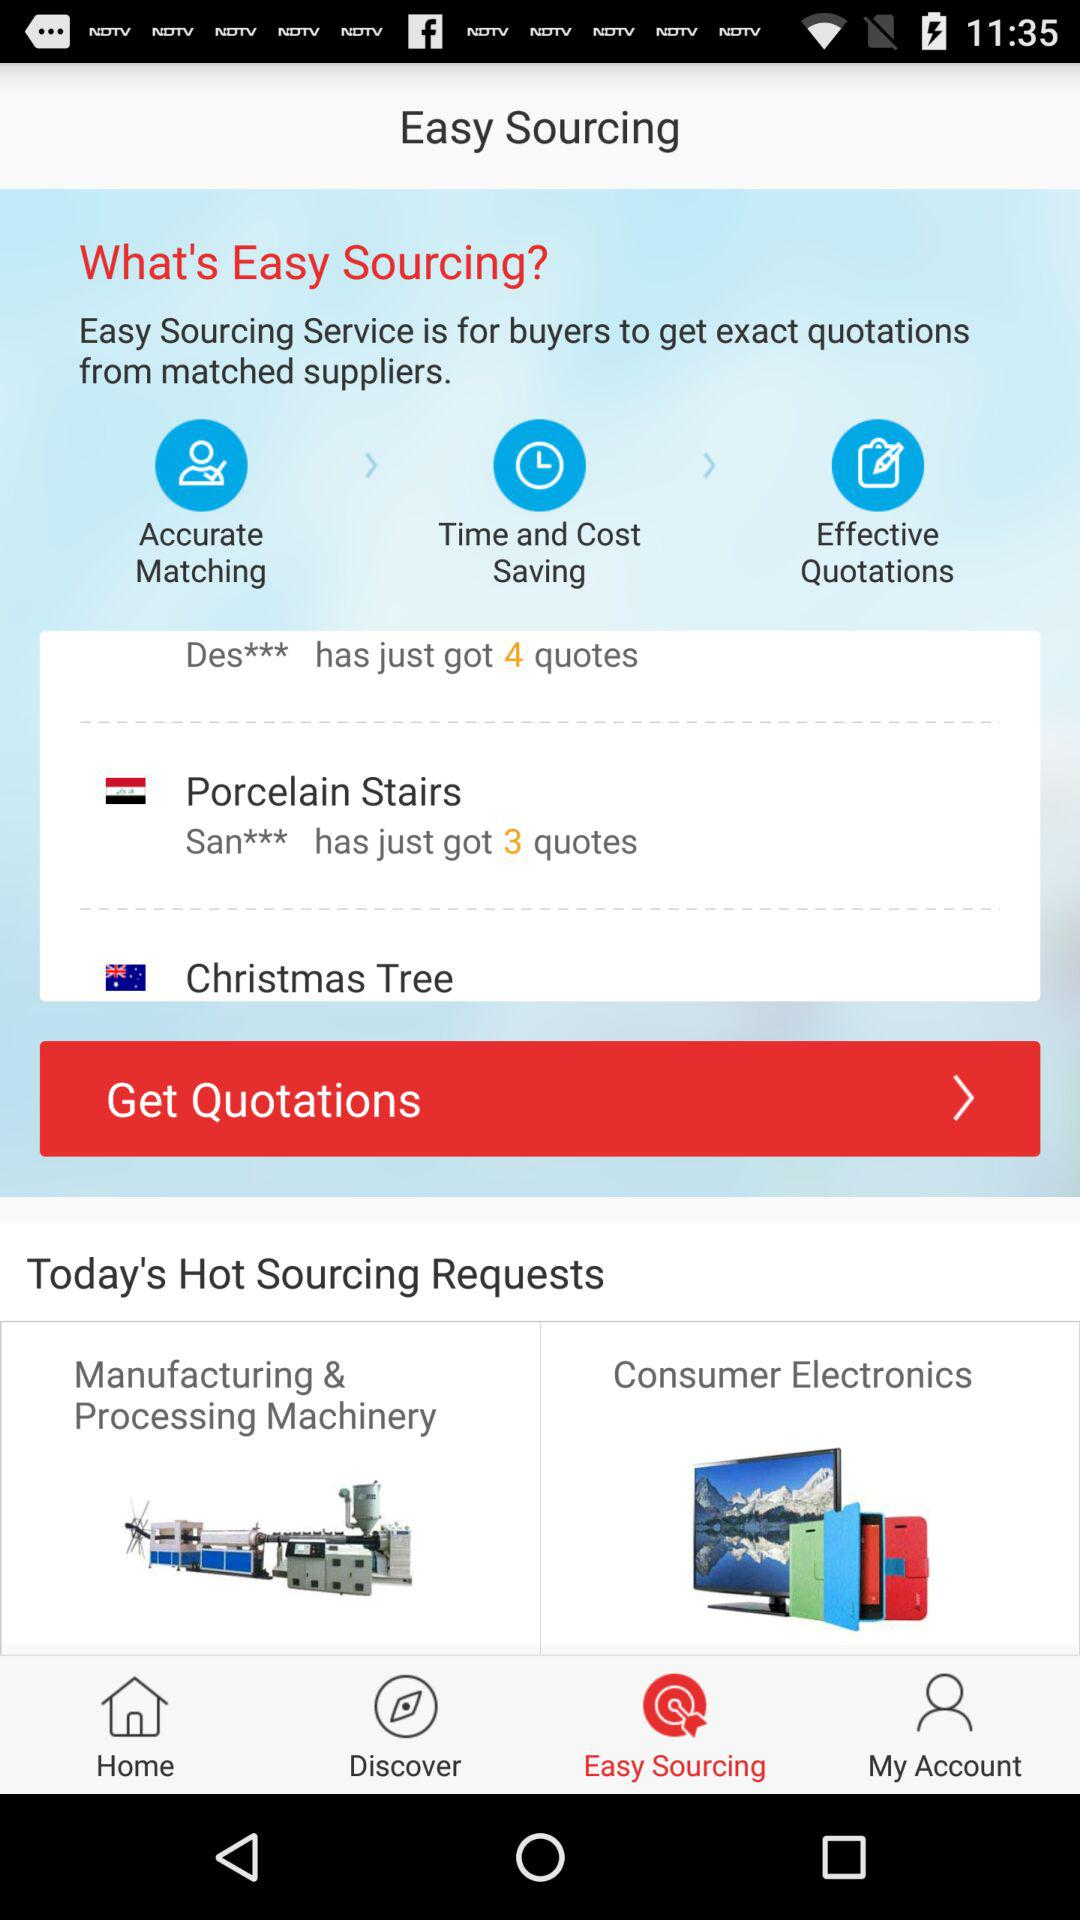How many more quotes does Des*** have than San***?
Answer the question using a single word or phrase. 1 